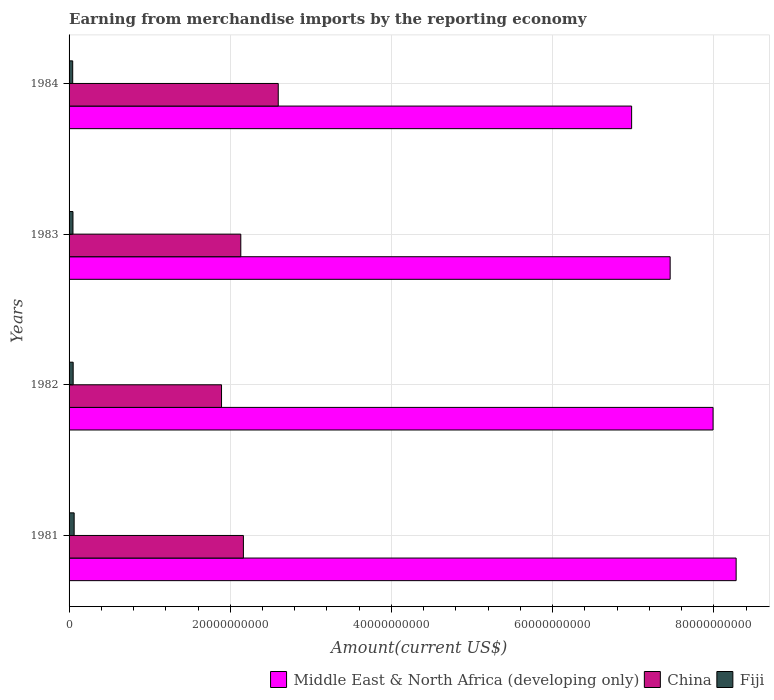How many different coloured bars are there?
Keep it short and to the point. 3. Are the number of bars per tick equal to the number of legend labels?
Provide a succinct answer. Yes. How many bars are there on the 3rd tick from the top?
Your answer should be compact. 3. How many bars are there on the 3rd tick from the bottom?
Provide a succinct answer. 3. In how many cases, is the number of bars for a given year not equal to the number of legend labels?
Keep it short and to the point. 0. What is the amount earned from merchandise imports in China in 1983?
Ensure brevity in your answer.  2.13e+1. Across all years, what is the maximum amount earned from merchandise imports in China?
Give a very brief answer. 2.60e+1. Across all years, what is the minimum amount earned from merchandise imports in China?
Your answer should be very brief. 1.89e+1. In which year was the amount earned from merchandise imports in Middle East & North Africa (developing only) maximum?
Give a very brief answer. 1981. What is the total amount earned from merchandise imports in Middle East & North Africa (developing only) in the graph?
Provide a succinct answer. 3.07e+11. What is the difference between the amount earned from merchandise imports in China in 1981 and that in 1983?
Provide a succinct answer. 3.24e+08. What is the difference between the amount earned from merchandise imports in Fiji in 1984 and the amount earned from merchandise imports in China in 1982?
Make the answer very short. -1.85e+1. What is the average amount earned from merchandise imports in China per year?
Your answer should be compact. 2.20e+1. In the year 1982, what is the difference between the amount earned from merchandise imports in China and amount earned from merchandise imports in Fiji?
Your answer should be compact. 1.84e+1. What is the ratio of the amount earned from merchandise imports in Fiji in 1981 to that in 1983?
Offer a terse response. 1.3. Is the difference between the amount earned from merchandise imports in China in 1982 and 1984 greater than the difference between the amount earned from merchandise imports in Fiji in 1982 and 1984?
Your answer should be very brief. No. What is the difference between the highest and the second highest amount earned from merchandise imports in Fiji?
Provide a short and direct response. 1.22e+08. What is the difference between the highest and the lowest amount earned from merchandise imports in Middle East & North Africa (developing only)?
Offer a terse response. 1.30e+1. In how many years, is the amount earned from merchandise imports in Fiji greater than the average amount earned from merchandise imports in Fiji taken over all years?
Provide a succinct answer. 1. Is the sum of the amount earned from merchandise imports in China in 1983 and 1984 greater than the maximum amount earned from merchandise imports in Fiji across all years?
Keep it short and to the point. Yes. What does the 2nd bar from the top in 1984 represents?
Make the answer very short. China. What does the 1st bar from the bottom in 1981 represents?
Keep it short and to the point. Middle East & North Africa (developing only). Is it the case that in every year, the sum of the amount earned from merchandise imports in Middle East & North Africa (developing only) and amount earned from merchandise imports in Fiji is greater than the amount earned from merchandise imports in China?
Ensure brevity in your answer.  Yes. How many bars are there?
Offer a very short reply. 12. Are all the bars in the graph horizontal?
Ensure brevity in your answer.  Yes. How many years are there in the graph?
Provide a short and direct response. 4. What is the title of the graph?
Give a very brief answer. Earning from merchandise imports by the reporting economy. Does "Portugal" appear as one of the legend labels in the graph?
Your answer should be very brief. No. What is the label or title of the X-axis?
Offer a terse response. Amount(current US$). What is the label or title of the Y-axis?
Your answer should be very brief. Years. What is the Amount(current US$) of Middle East & North Africa (developing only) in 1981?
Provide a short and direct response. 8.28e+1. What is the Amount(current US$) of China in 1981?
Your answer should be very brief. 2.16e+1. What is the Amount(current US$) of Fiji in 1981?
Your response must be concise. 6.32e+08. What is the Amount(current US$) in Middle East & North Africa (developing only) in 1982?
Offer a terse response. 7.99e+1. What is the Amount(current US$) in China in 1982?
Give a very brief answer. 1.89e+1. What is the Amount(current US$) in Fiji in 1982?
Your answer should be very brief. 5.09e+08. What is the Amount(current US$) of Middle East & North Africa (developing only) in 1983?
Make the answer very short. 7.46e+1. What is the Amount(current US$) in China in 1983?
Your answer should be compact. 2.13e+1. What is the Amount(current US$) of Fiji in 1983?
Your answer should be compact. 4.84e+08. What is the Amount(current US$) of Middle East & North Africa (developing only) in 1984?
Your response must be concise. 6.98e+1. What is the Amount(current US$) of China in 1984?
Provide a short and direct response. 2.60e+1. What is the Amount(current US$) of Fiji in 1984?
Offer a very short reply. 4.50e+08. Across all years, what is the maximum Amount(current US$) of Middle East & North Africa (developing only)?
Ensure brevity in your answer.  8.28e+1. Across all years, what is the maximum Amount(current US$) in China?
Ensure brevity in your answer.  2.60e+1. Across all years, what is the maximum Amount(current US$) in Fiji?
Make the answer very short. 6.32e+08. Across all years, what is the minimum Amount(current US$) of Middle East & North Africa (developing only)?
Your response must be concise. 6.98e+1. Across all years, what is the minimum Amount(current US$) of China?
Make the answer very short. 1.89e+1. Across all years, what is the minimum Amount(current US$) of Fiji?
Make the answer very short. 4.50e+08. What is the total Amount(current US$) in Middle East & North Africa (developing only) in the graph?
Offer a very short reply. 3.07e+11. What is the total Amount(current US$) in China in the graph?
Make the answer very short. 8.78e+1. What is the total Amount(current US$) in Fiji in the graph?
Ensure brevity in your answer.  2.08e+09. What is the difference between the Amount(current US$) of Middle East & North Africa (developing only) in 1981 and that in 1982?
Offer a very short reply. 2.86e+09. What is the difference between the Amount(current US$) in China in 1981 and that in 1982?
Give a very brief answer. 2.71e+09. What is the difference between the Amount(current US$) of Fiji in 1981 and that in 1982?
Provide a short and direct response. 1.22e+08. What is the difference between the Amount(current US$) in Middle East & North Africa (developing only) in 1981 and that in 1983?
Offer a very short reply. 8.19e+09. What is the difference between the Amount(current US$) in China in 1981 and that in 1983?
Give a very brief answer. 3.24e+08. What is the difference between the Amount(current US$) in Fiji in 1981 and that in 1983?
Keep it short and to the point. 1.47e+08. What is the difference between the Amount(current US$) of Middle East & North Africa (developing only) in 1981 and that in 1984?
Provide a succinct answer. 1.30e+1. What is the difference between the Amount(current US$) of China in 1981 and that in 1984?
Your response must be concise. -4.32e+09. What is the difference between the Amount(current US$) in Fiji in 1981 and that in 1984?
Your answer should be very brief. 1.82e+08. What is the difference between the Amount(current US$) in Middle East & North Africa (developing only) in 1982 and that in 1983?
Ensure brevity in your answer.  5.33e+09. What is the difference between the Amount(current US$) of China in 1982 and that in 1983?
Keep it short and to the point. -2.39e+09. What is the difference between the Amount(current US$) in Fiji in 1982 and that in 1983?
Ensure brevity in your answer.  2.50e+07. What is the difference between the Amount(current US$) in Middle East & North Africa (developing only) in 1982 and that in 1984?
Keep it short and to the point. 1.01e+1. What is the difference between the Amount(current US$) in China in 1982 and that in 1984?
Keep it short and to the point. -7.04e+09. What is the difference between the Amount(current US$) in Fiji in 1982 and that in 1984?
Your answer should be very brief. 5.96e+07. What is the difference between the Amount(current US$) of Middle East & North Africa (developing only) in 1983 and that in 1984?
Offer a very short reply. 4.78e+09. What is the difference between the Amount(current US$) in China in 1983 and that in 1984?
Give a very brief answer. -4.65e+09. What is the difference between the Amount(current US$) in Fiji in 1983 and that in 1984?
Keep it short and to the point. 3.46e+07. What is the difference between the Amount(current US$) of Middle East & North Africa (developing only) in 1981 and the Amount(current US$) of China in 1982?
Your answer should be very brief. 6.39e+1. What is the difference between the Amount(current US$) of Middle East & North Africa (developing only) in 1981 and the Amount(current US$) of Fiji in 1982?
Provide a succinct answer. 8.23e+1. What is the difference between the Amount(current US$) in China in 1981 and the Amount(current US$) in Fiji in 1982?
Offer a very short reply. 2.11e+1. What is the difference between the Amount(current US$) in Middle East & North Africa (developing only) in 1981 and the Amount(current US$) in China in 1983?
Give a very brief answer. 6.15e+1. What is the difference between the Amount(current US$) in Middle East & North Africa (developing only) in 1981 and the Amount(current US$) in Fiji in 1983?
Your response must be concise. 8.23e+1. What is the difference between the Amount(current US$) of China in 1981 and the Amount(current US$) of Fiji in 1983?
Keep it short and to the point. 2.11e+1. What is the difference between the Amount(current US$) of Middle East & North Africa (developing only) in 1981 and the Amount(current US$) of China in 1984?
Your response must be concise. 5.68e+1. What is the difference between the Amount(current US$) of Middle East & North Africa (developing only) in 1981 and the Amount(current US$) of Fiji in 1984?
Your answer should be compact. 8.23e+1. What is the difference between the Amount(current US$) in China in 1981 and the Amount(current US$) in Fiji in 1984?
Give a very brief answer. 2.12e+1. What is the difference between the Amount(current US$) of Middle East & North Africa (developing only) in 1982 and the Amount(current US$) of China in 1983?
Ensure brevity in your answer.  5.86e+1. What is the difference between the Amount(current US$) of Middle East & North Africa (developing only) in 1982 and the Amount(current US$) of Fiji in 1983?
Offer a terse response. 7.94e+1. What is the difference between the Amount(current US$) of China in 1982 and the Amount(current US$) of Fiji in 1983?
Provide a short and direct response. 1.84e+1. What is the difference between the Amount(current US$) of Middle East & North Africa (developing only) in 1982 and the Amount(current US$) of China in 1984?
Offer a terse response. 5.40e+1. What is the difference between the Amount(current US$) in Middle East & North Africa (developing only) in 1982 and the Amount(current US$) in Fiji in 1984?
Provide a short and direct response. 7.95e+1. What is the difference between the Amount(current US$) of China in 1982 and the Amount(current US$) of Fiji in 1984?
Your answer should be compact. 1.85e+1. What is the difference between the Amount(current US$) in Middle East & North Africa (developing only) in 1983 and the Amount(current US$) in China in 1984?
Provide a short and direct response. 4.86e+1. What is the difference between the Amount(current US$) of Middle East & North Africa (developing only) in 1983 and the Amount(current US$) of Fiji in 1984?
Keep it short and to the point. 7.41e+1. What is the difference between the Amount(current US$) in China in 1983 and the Amount(current US$) in Fiji in 1984?
Your answer should be very brief. 2.09e+1. What is the average Amount(current US$) of Middle East & North Africa (developing only) per year?
Your response must be concise. 7.68e+1. What is the average Amount(current US$) in China per year?
Provide a succinct answer. 2.20e+1. What is the average Amount(current US$) in Fiji per year?
Your response must be concise. 5.19e+08. In the year 1981, what is the difference between the Amount(current US$) of Middle East & North Africa (developing only) and Amount(current US$) of China?
Your answer should be very brief. 6.11e+1. In the year 1981, what is the difference between the Amount(current US$) of Middle East & North Africa (developing only) and Amount(current US$) of Fiji?
Make the answer very short. 8.21e+1. In the year 1981, what is the difference between the Amount(current US$) of China and Amount(current US$) of Fiji?
Provide a succinct answer. 2.10e+1. In the year 1982, what is the difference between the Amount(current US$) in Middle East & North Africa (developing only) and Amount(current US$) in China?
Your response must be concise. 6.10e+1. In the year 1982, what is the difference between the Amount(current US$) in Middle East & North Africa (developing only) and Amount(current US$) in Fiji?
Offer a very short reply. 7.94e+1. In the year 1982, what is the difference between the Amount(current US$) of China and Amount(current US$) of Fiji?
Offer a terse response. 1.84e+1. In the year 1983, what is the difference between the Amount(current US$) in Middle East & North Africa (developing only) and Amount(current US$) in China?
Keep it short and to the point. 5.33e+1. In the year 1983, what is the difference between the Amount(current US$) in Middle East & North Africa (developing only) and Amount(current US$) in Fiji?
Your response must be concise. 7.41e+1. In the year 1983, what is the difference between the Amount(current US$) in China and Amount(current US$) in Fiji?
Provide a succinct answer. 2.08e+1. In the year 1984, what is the difference between the Amount(current US$) in Middle East & North Africa (developing only) and Amount(current US$) in China?
Offer a terse response. 4.38e+1. In the year 1984, what is the difference between the Amount(current US$) in Middle East & North Africa (developing only) and Amount(current US$) in Fiji?
Offer a terse response. 6.94e+1. In the year 1984, what is the difference between the Amount(current US$) in China and Amount(current US$) in Fiji?
Make the answer very short. 2.55e+1. What is the ratio of the Amount(current US$) of Middle East & North Africa (developing only) in 1981 to that in 1982?
Provide a short and direct response. 1.04. What is the ratio of the Amount(current US$) in China in 1981 to that in 1982?
Your answer should be very brief. 1.14. What is the ratio of the Amount(current US$) of Fiji in 1981 to that in 1982?
Provide a short and direct response. 1.24. What is the ratio of the Amount(current US$) of Middle East & North Africa (developing only) in 1981 to that in 1983?
Give a very brief answer. 1.11. What is the ratio of the Amount(current US$) of China in 1981 to that in 1983?
Offer a very short reply. 1.02. What is the ratio of the Amount(current US$) of Fiji in 1981 to that in 1983?
Your answer should be very brief. 1.3. What is the ratio of the Amount(current US$) of Middle East & North Africa (developing only) in 1981 to that in 1984?
Ensure brevity in your answer.  1.19. What is the ratio of the Amount(current US$) in China in 1981 to that in 1984?
Provide a succinct answer. 0.83. What is the ratio of the Amount(current US$) of Fiji in 1981 to that in 1984?
Make the answer very short. 1.4. What is the ratio of the Amount(current US$) in Middle East & North Africa (developing only) in 1982 to that in 1983?
Provide a succinct answer. 1.07. What is the ratio of the Amount(current US$) of China in 1982 to that in 1983?
Your answer should be compact. 0.89. What is the ratio of the Amount(current US$) of Fiji in 1982 to that in 1983?
Offer a terse response. 1.05. What is the ratio of the Amount(current US$) in Middle East & North Africa (developing only) in 1982 to that in 1984?
Give a very brief answer. 1.14. What is the ratio of the Amount(current US$) of China in 1982 to that in 1984?
Your answer should be very brief. 0.73. What is the ratio of the Amount(current US$) in Fiji in 1982 to that in 1984?
Your response must be concise. 1.13. What is the ratio of the Amount(current US$) of Middle East & North Africa (developing only) in 1983 to that in 1984?
Your response must be concise. 1.07. What is the ratio of the Amount(current US$) of China in 1983 to that in 1984?
Offer a terse response. 0.82. What is the ratio of the Amount(current US$) in Fiji in 1983 to that in 1984?
Your response must be concise. 1.08. What is the difference between the highest and the second highest Amount(current US$) in Middle East & North Africa (developing only)?
Offer a terse response. 2.86e+09. What is the difference between the highest and the second highest Amount(current US$) in China?
Provide a succinct answer. 4.32e+09. What is the difference between the highest and the second highest Amount(current US$) of Fiji?
Offer a very short reply. 1.22e+08. What is the difference between the highest and the lowest Amount(current US$) of Middle East & North Africa (developing only)?
Offer a very short reply. 1.30e+1. What is the difference between the highest and the lowest Amount(current US$) in China?
Make the answer very short. 7.04e+09. What is the difference between the highest and the lowest Amount(current US$) of Fiji?
Keep it short and to the point. 1.82e+08. 